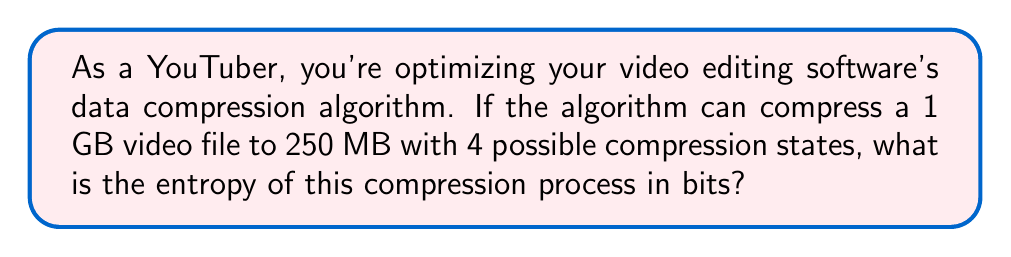Give your solution to this math problem. To calculate the entropy of the data compression algorithm, we'll follow these steps:

1. Determine the compression ratio:
   $$ \text{Compression Ratio} = \frac{\text{Original Size}}{\text{Compressed Size}} = \frac{1 \text{ GB}}{250 \text{ MB}} = \frac{1000 \text{ MB}}{250 \text{ MB}} = 4 $$

2. Calculate the probability of each compression state:
   Since there are 4 possible compression states and we assume they are equally likely:
   $$ p_i = \frac{1}{4} \text{ for each state} $$

3. Apply the entropy formula:
   $$ S = -k \sum_{i=1}^{n} p_i \log_2(p_i) $$
   Where:
   - $S$ is the entropy
   - $k$ is Boltzmann's constant (in this case, we use 1 for information entropy)
   - $n$ is the number of possible states (4 in this case)
   - $p_i$ is the probability of each state

4. Substitute the values:
   $$ S = -1 \cdot \left(4 \cdot \frac{1}{4} \log_2\left(\frac{1}{4}\right)\right) $$

5. Simplify:
   $$ S = -\left(\log_2\left(\frac{1}{4}\right)\right) = -(-2) = 2 \text{ bits} $$

The entropy of the compression process is 2 bits.
Answer: 2 bits 